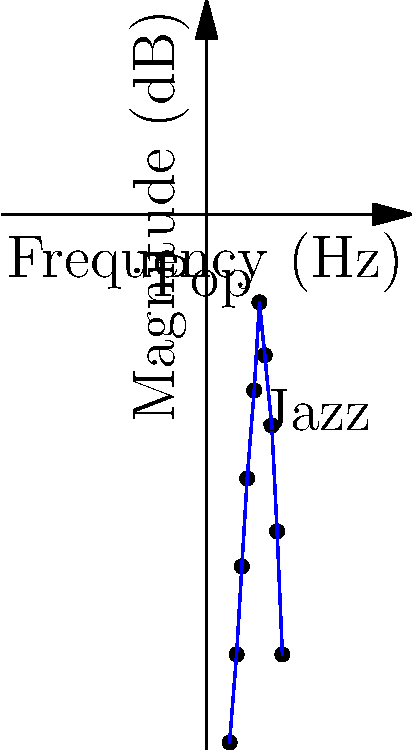You're analyzing the frequency spectrum of your latest jazz-pop fusion song. The graph shows the magnitude response of the song across the audible frequency range. What technique would you use to enhance the jazz elements in the mix while maintaining the overall pop feel, and why? To enhance the jazz elements while maintaining the pop feel, we need to consider the following steps:

1. Analyze the frequency spectrum:
   - Jazz typically emphasizes lower-mid frequencies (around 200-500 Hz)
   - Pop music often has a boost in the higher frequencies (1-5 kHz)

2. Identify the jazz elements:
   - The graph shows a peak around 200 Hz, likely corresponding to jazz instruments

3. Enhance jazz frequencies:
   - Apply a gentle boost (2-3 dB) in the 200-500 Hz range using a parametric EQ
   - This will bring out the warmth and body of jazz instruments like upright bass and piano

4. Maintain pop characteristics:
   - Keep the existing peak around 2-5 kHz, which gives pop its crisp, clear sound
   - Avoid over-boosting this range to prevent masking jazz elements

5. Balance the mix:
   - Use multiband compression to control the dynamics in both jazz and pop frequency ranges
   - This ensures neither element overpowers the other

6. Apply subtle saturation:
   - Add harmonic content to the jazz frequencies (200-500 Hz) to help them cut through the mix without increasing volume

The technique to use is a combination of equalization, multiband compression, and subtle saturation. This approach enhances the jazz elements by boosting their characteristic frequencies and adding harmonic content, while maintaining the pop feel by preserving the existing high-frequency content and overall balance.
Answer: Equalization, multiband compression, and subtle saturation 